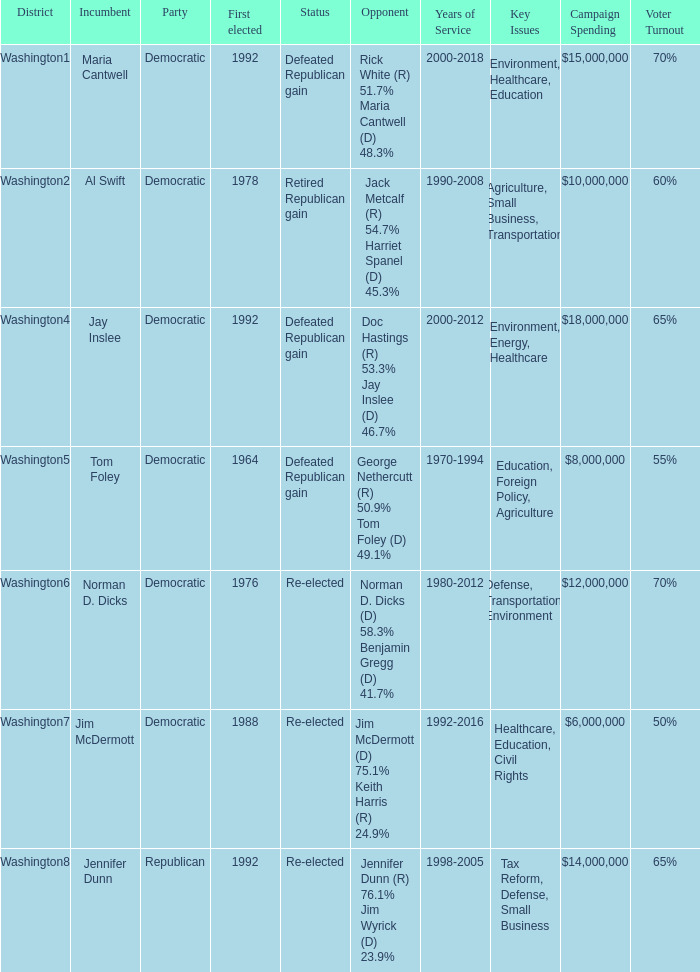In the election with doc hastings (r) at 53.3% and jay inslee (d) at 46.7%, what was the final result? Defeated Republican gain. 